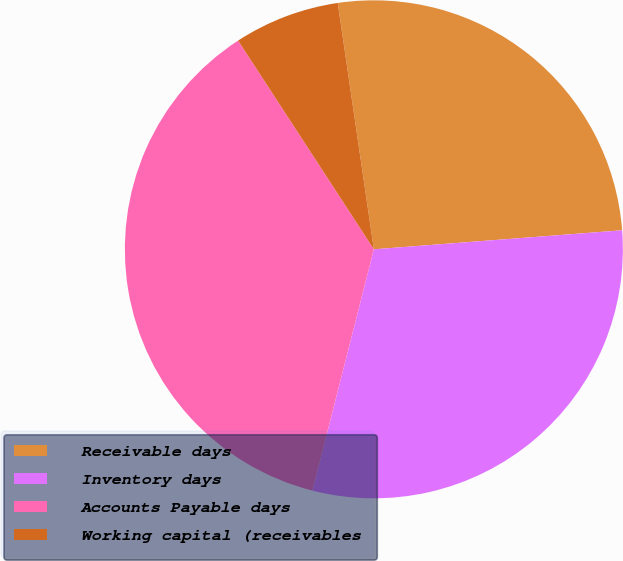Convert chart to OTSL. <chart><loc_0><loc_0><loc_500><loc_500><pie_chart><fcel>Receivable days<fcel>Inventory days<fcel>Accounts Payable days<fcel>Working capital (receivables<nl><fcel>26.1%<fcel>30.19%<fcel>36.85%<fcel>6.86%<nl></chart> 